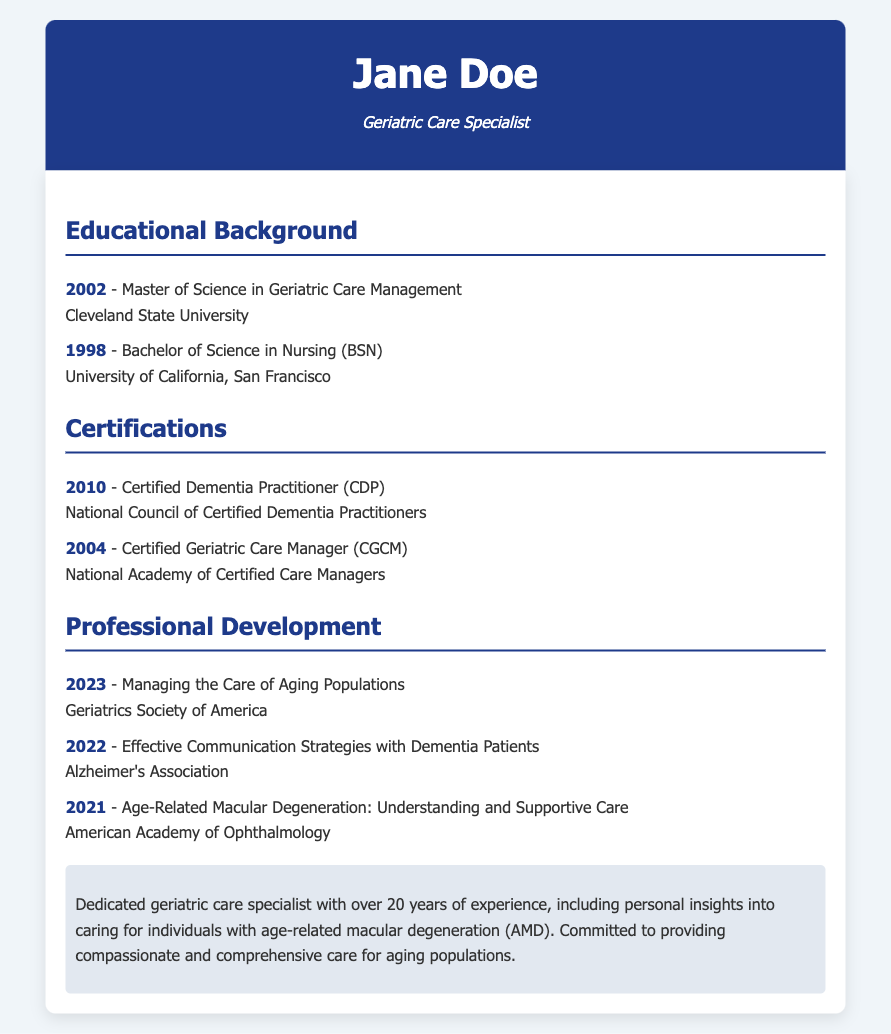What degree did Jane Doe earn in 2002? The document states that Jane Doe earned a Master of Science in Geriatric Care Management in 2002.
Answer: Master of Science in Geriatric Care Management When did Jane Doe become a Certified Dementia Practitioner? The document lists that Jane Doe received the Certified Dementia Practitioner certification in 2010.
Answer: 2010 What organization certified Jane Doe as a Certified Geriatric Care Manager? According to the document, the certification was granted by the National Academy of Certified Care Managers.
Answer: National Academy of Certified Care Managers How many years of experience does Jane Doe have in geriatric care? The document mentions that Jane Doe has over 20 years of experience in geriatric care.
Answer: Over 20 years What workshop did Jane Doe attend in 2021? The document specifies that she attended the workshop titled "Age-Related Macular Degeneration: Understanding and Supportive Care" in 2021.
Answer: Age-Related Macular Degeneration: Understanding and Supportive Care Which university did Jane Doe attend for her Bachelor of Science in Nursing? The document identifies the University of California, San Francisco as the institution where she obtained her BSN.
Answer: University of California, San Francisco What is the subtitle of Jane Doe's resume? The document indicates that the subtitle of Jane Doe's resume is "Geriatric Care Specialist."
Answer: Geriatric Care Specialist What year did Jane Doe attend the workshop on effective communication strategies with dementia patients? The document states that she attended the workshop in 2022.
Answer: 2022 